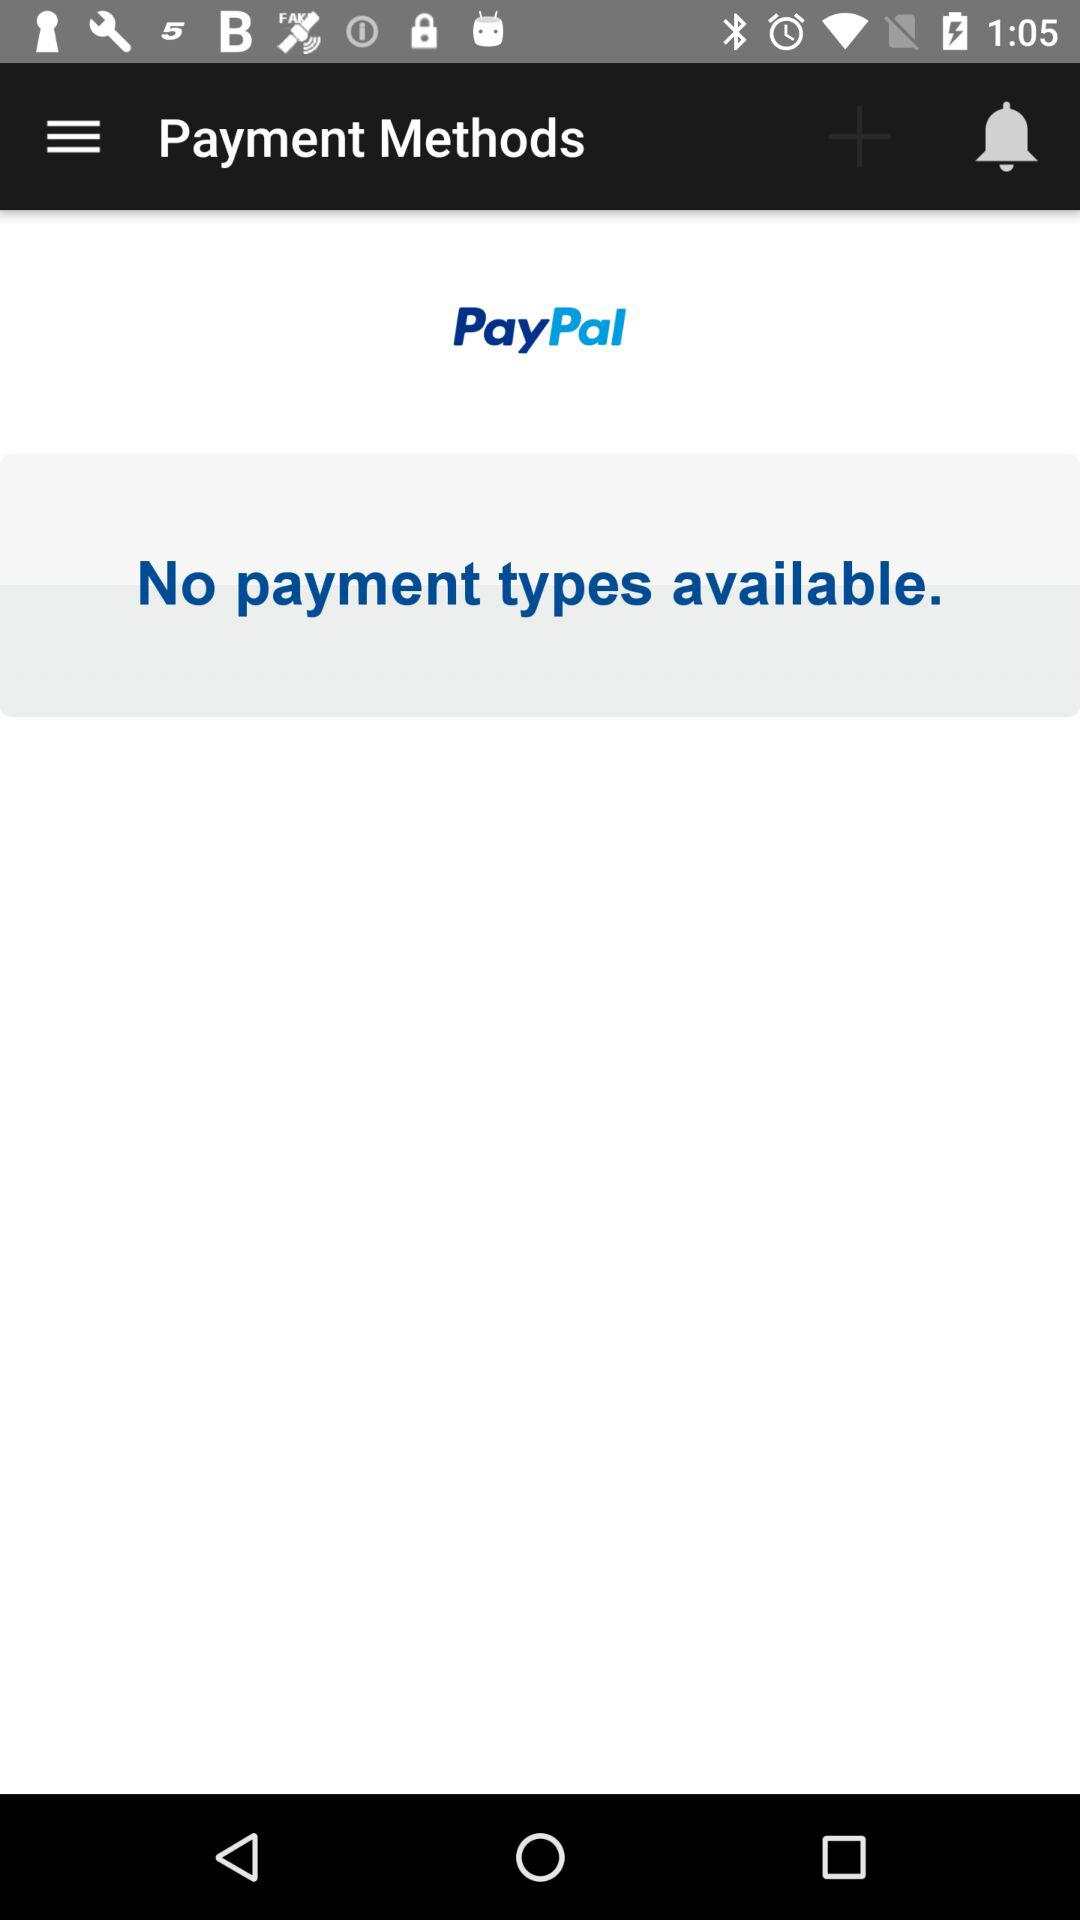Through what application can we make the payment? You can make the payment through "PayPal". 